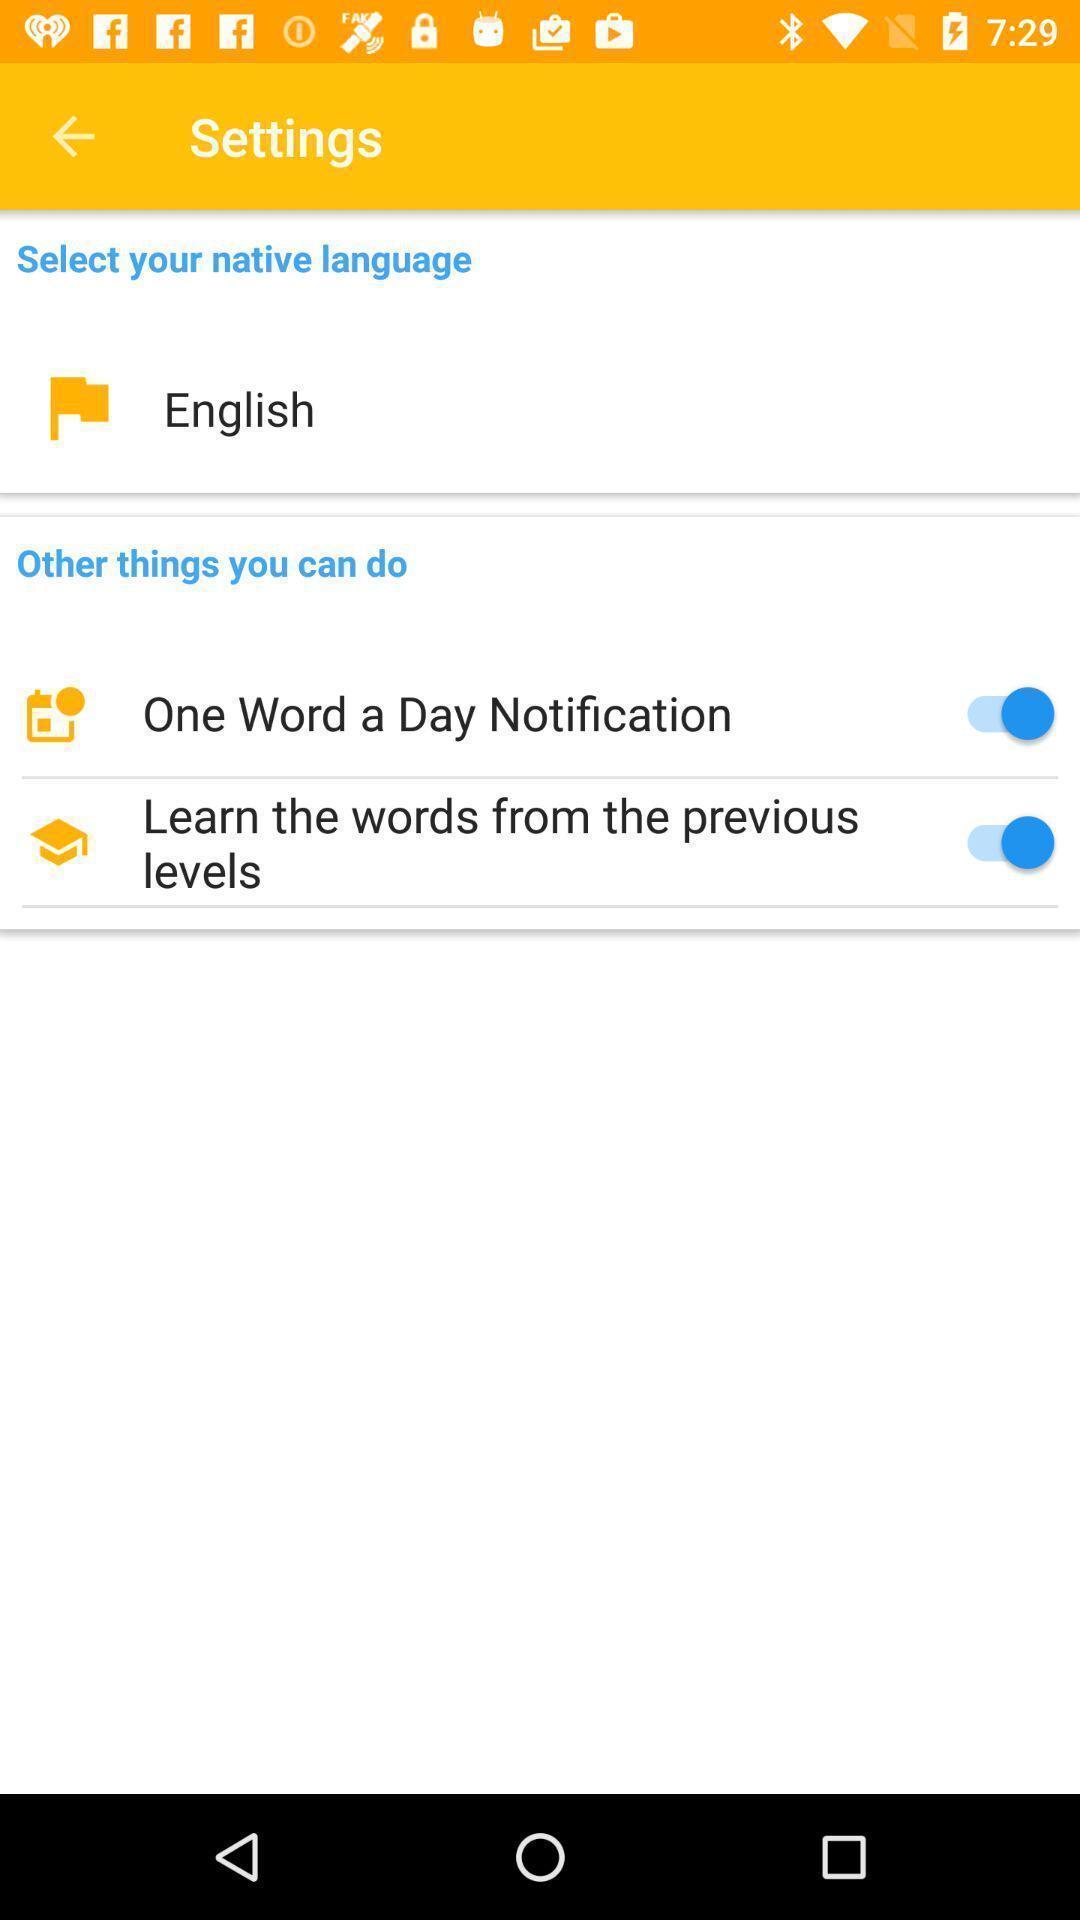Provide a description of this screenshot. Settings of the language learning app. 